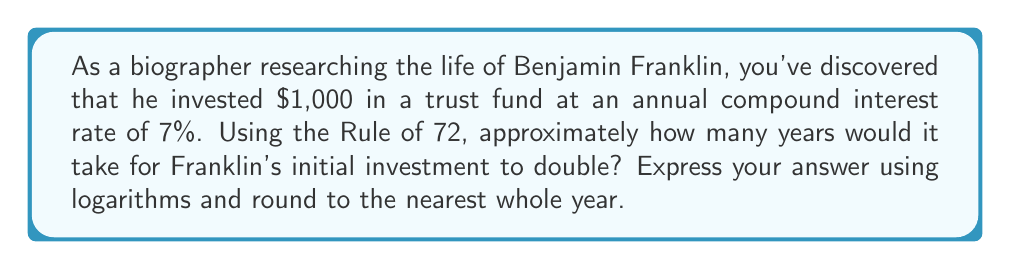Could you help me with this problem? To solve this problem, we'll use the Rule of 72 and logarithms. The Rule of 72 is an approximation that relates the doubling time of an investment to its interest rate.

1) The Rule of 72 states that:
   $$ \text{Years to double} \approx \frac{72}{\text{Interest Rate (%)}} $$

2) In this case, the interest rate is 7%. Substituting this into the formula:
   $$ \text{Years to double} \approx \frac{72}{7} $$

3) To calculate this more precisely, we can use logarithms. The exact formula for doubling time with compound interest is:
   $$ t = \frac{\ln(2)}{\ln(1 + r)} $$
   Where $t$ is the time to double, and $r$ is the interest rate as a decimal.

4) Substituting $r = 0.07$ (7% as a decimal):
   $$ t = \frac{\ln(2)}{\ln(1.07)} $$

5) Using a calculator or computer:
   $$ t \approx 10.24457 \text{ years} $$

6) Rounding to the nearest whole year:
   $$ t \approx 10 \text{ years} $$

This result aligns closely with the Rule of 72 approximation ($72/7 \approx 10.29$), demonstrating the rule's effectiveness for quick estimates.
Answer: 10 years 